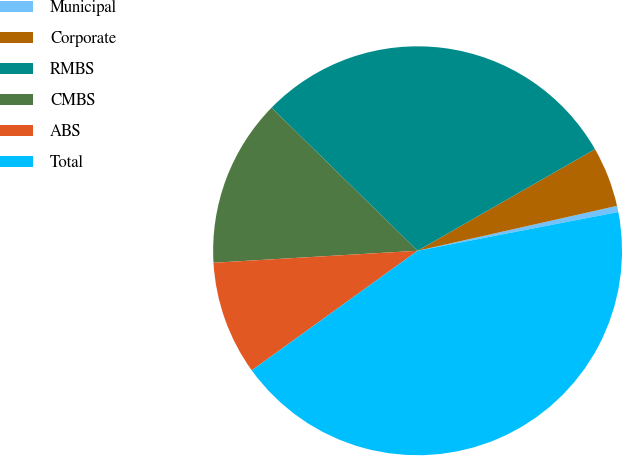<chart> <loc_0><loc_0><loc_500><loc_500><pie_chart><fcel>Municipal<fcel>Corporate<fcel>RMBS<fcel>CMBS<fcel>ABS<fcel>Total<nl><fcel>0.49%<fcel>4.75%<fcel>29.38%<fcel>13.27%<fcel>9.01%<fcel>43.08%<nl></chart> 